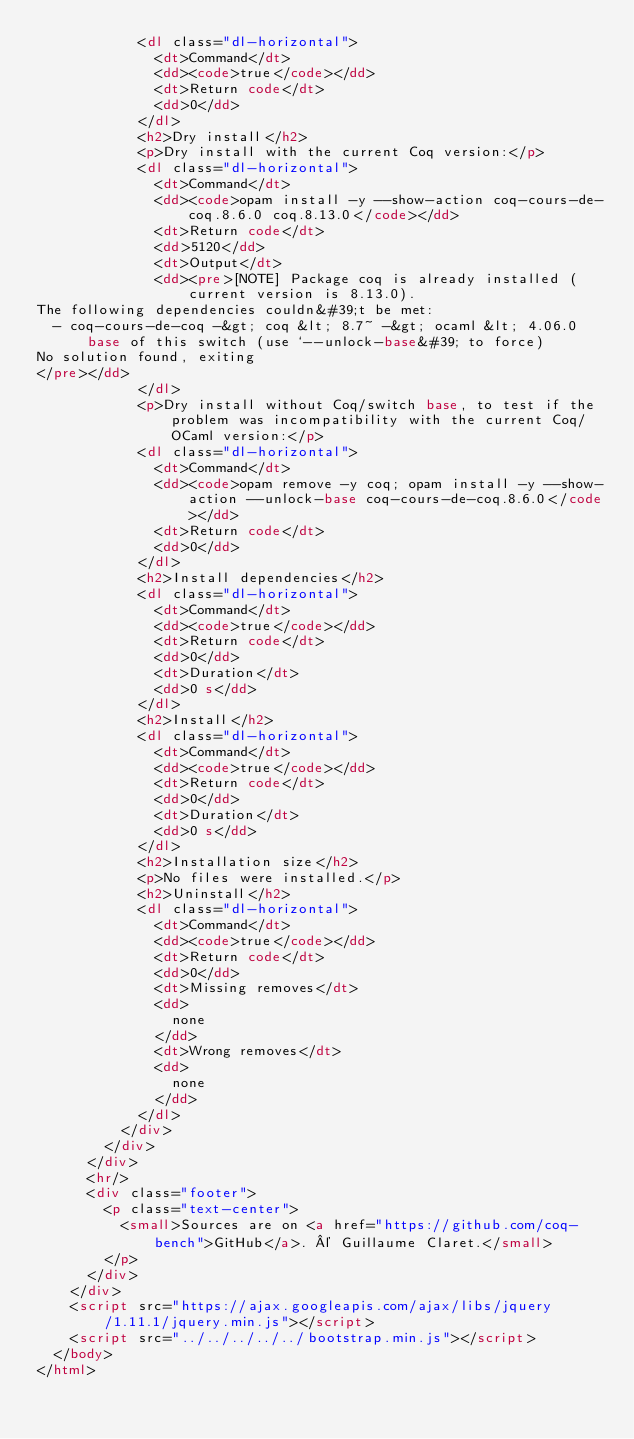<code> <loc_0><loc_0><loc_500><loc_500><_HTML_>            <dl class="dl-horizontal">
              <dt>Command</dt>
              <dd><code>true</code></dd>
              <dt>Return code</dt>
              <dd>0</dd>
            </dl>
            <h2>Dry install</h2>
            <p>Dry install with the current Coq version:</p>
            <dl class="dl-horizontal">
              <dt>Command</dt>
              <dd><code>opam install -y --show-action coq-cours-de-coq.8.6.0 coq.8.13.0</code></dd>
              <dt>Return code</dt>
              <dd>5120</dd>
              <dt>Output</dt>
              <dd><pre>[NOTE] Package coq is already installed (current version is 8.13.0).
The following dependencies couldn&#39;t be met:
  - coq-cours-de-coq -&gt; coq &lt; 8.7~ -&gt; ocaml &lt; 4.06.0
      base of this switch (use `--unlock-base&#39; to force)
No solution found, exiting
</pre></dd>
            </dl>
            <p>Dry install without Coq/switch base, to test if the problem was incompatibility with the current Coq/OCaml version:</p>
            <dl class="dl-horizontal">
              <dt>Command</dt>
              <dd><code>opam remove -y coq; opam install -y --show-action --unlock-base coq-cours-de-coq.8.6.0</code></dd>
              <dt>Return code</dt>
              <dd>0</dd>
            </dl>
            <h2>Install dependencies</h2>
            <dl class="dl-horizontal">
              <dt>Command</dt>
              <dd><code>true</code></dd>
              <dt>Return code</dt>
              <dd>0</dd>
              <dt>Duration</dt>
              <dd>0 s</dd>
            </dl>
            <h2>Install</h2>
            <dl class="dl-horizontal">
              <dt>Command</dt>
              <dd><code>true</code></dd>
              <dt>Return code</dt>
              <dd>0</dd>
              <dt>Duration</dt>
              <dd>0 s</dd>
            </dl>
            <h2>Installation size</h2>
            <p>No files were installed.</p>
            <h2>Uninstall</h2>
            <dl class="dl-horizontal">
              <dt>Command</dt>
              <dd><code>true</code></dd>
              <dt>Return code</dt>
              <dd>0</dd>
              <dt>Missing removes</dt>
              <dd>
                none
              </dd>
              <dt>Wrong removes</dt>
              <dd>
                none
              </dd>
            </dl>
          </div>
        </div>
      </div>
      <hr/>
      <div class="footer">
        <p class="text-center">
          <small>Sources are on <a href="https://github.com/coq-bench">GitHub</a>. © Guillaume Claret.</small>
        </p>
      </div>
    </div>
    <script src="https://ajax.googleapis.com/ajax/libs/jquery/1.11.1/jquery.min.js"></script>
    <script src="../../../../../bootstrap.min.js"></script>
  </body>
</html>
</code> 